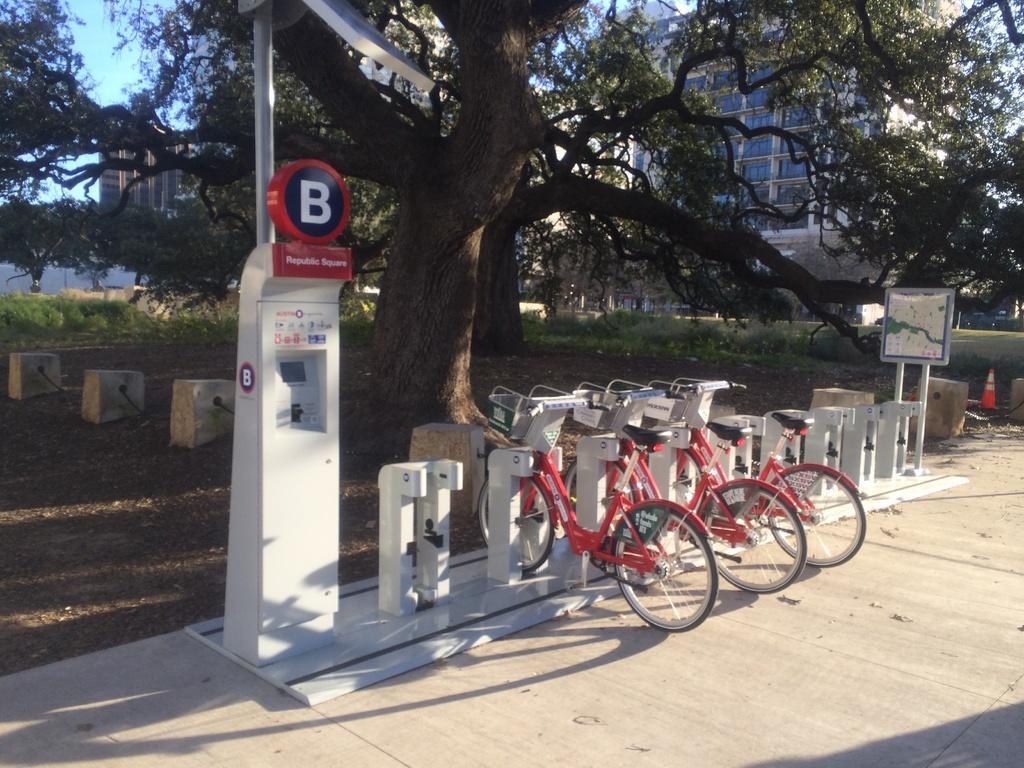Could you give a brief overview of what you see in this image? In this image we can see a group of bicycles placed on the ground, a device is placed on the ground. In the background, we can see a board with a map placed on stands, group of trees, buildings and the sky. 